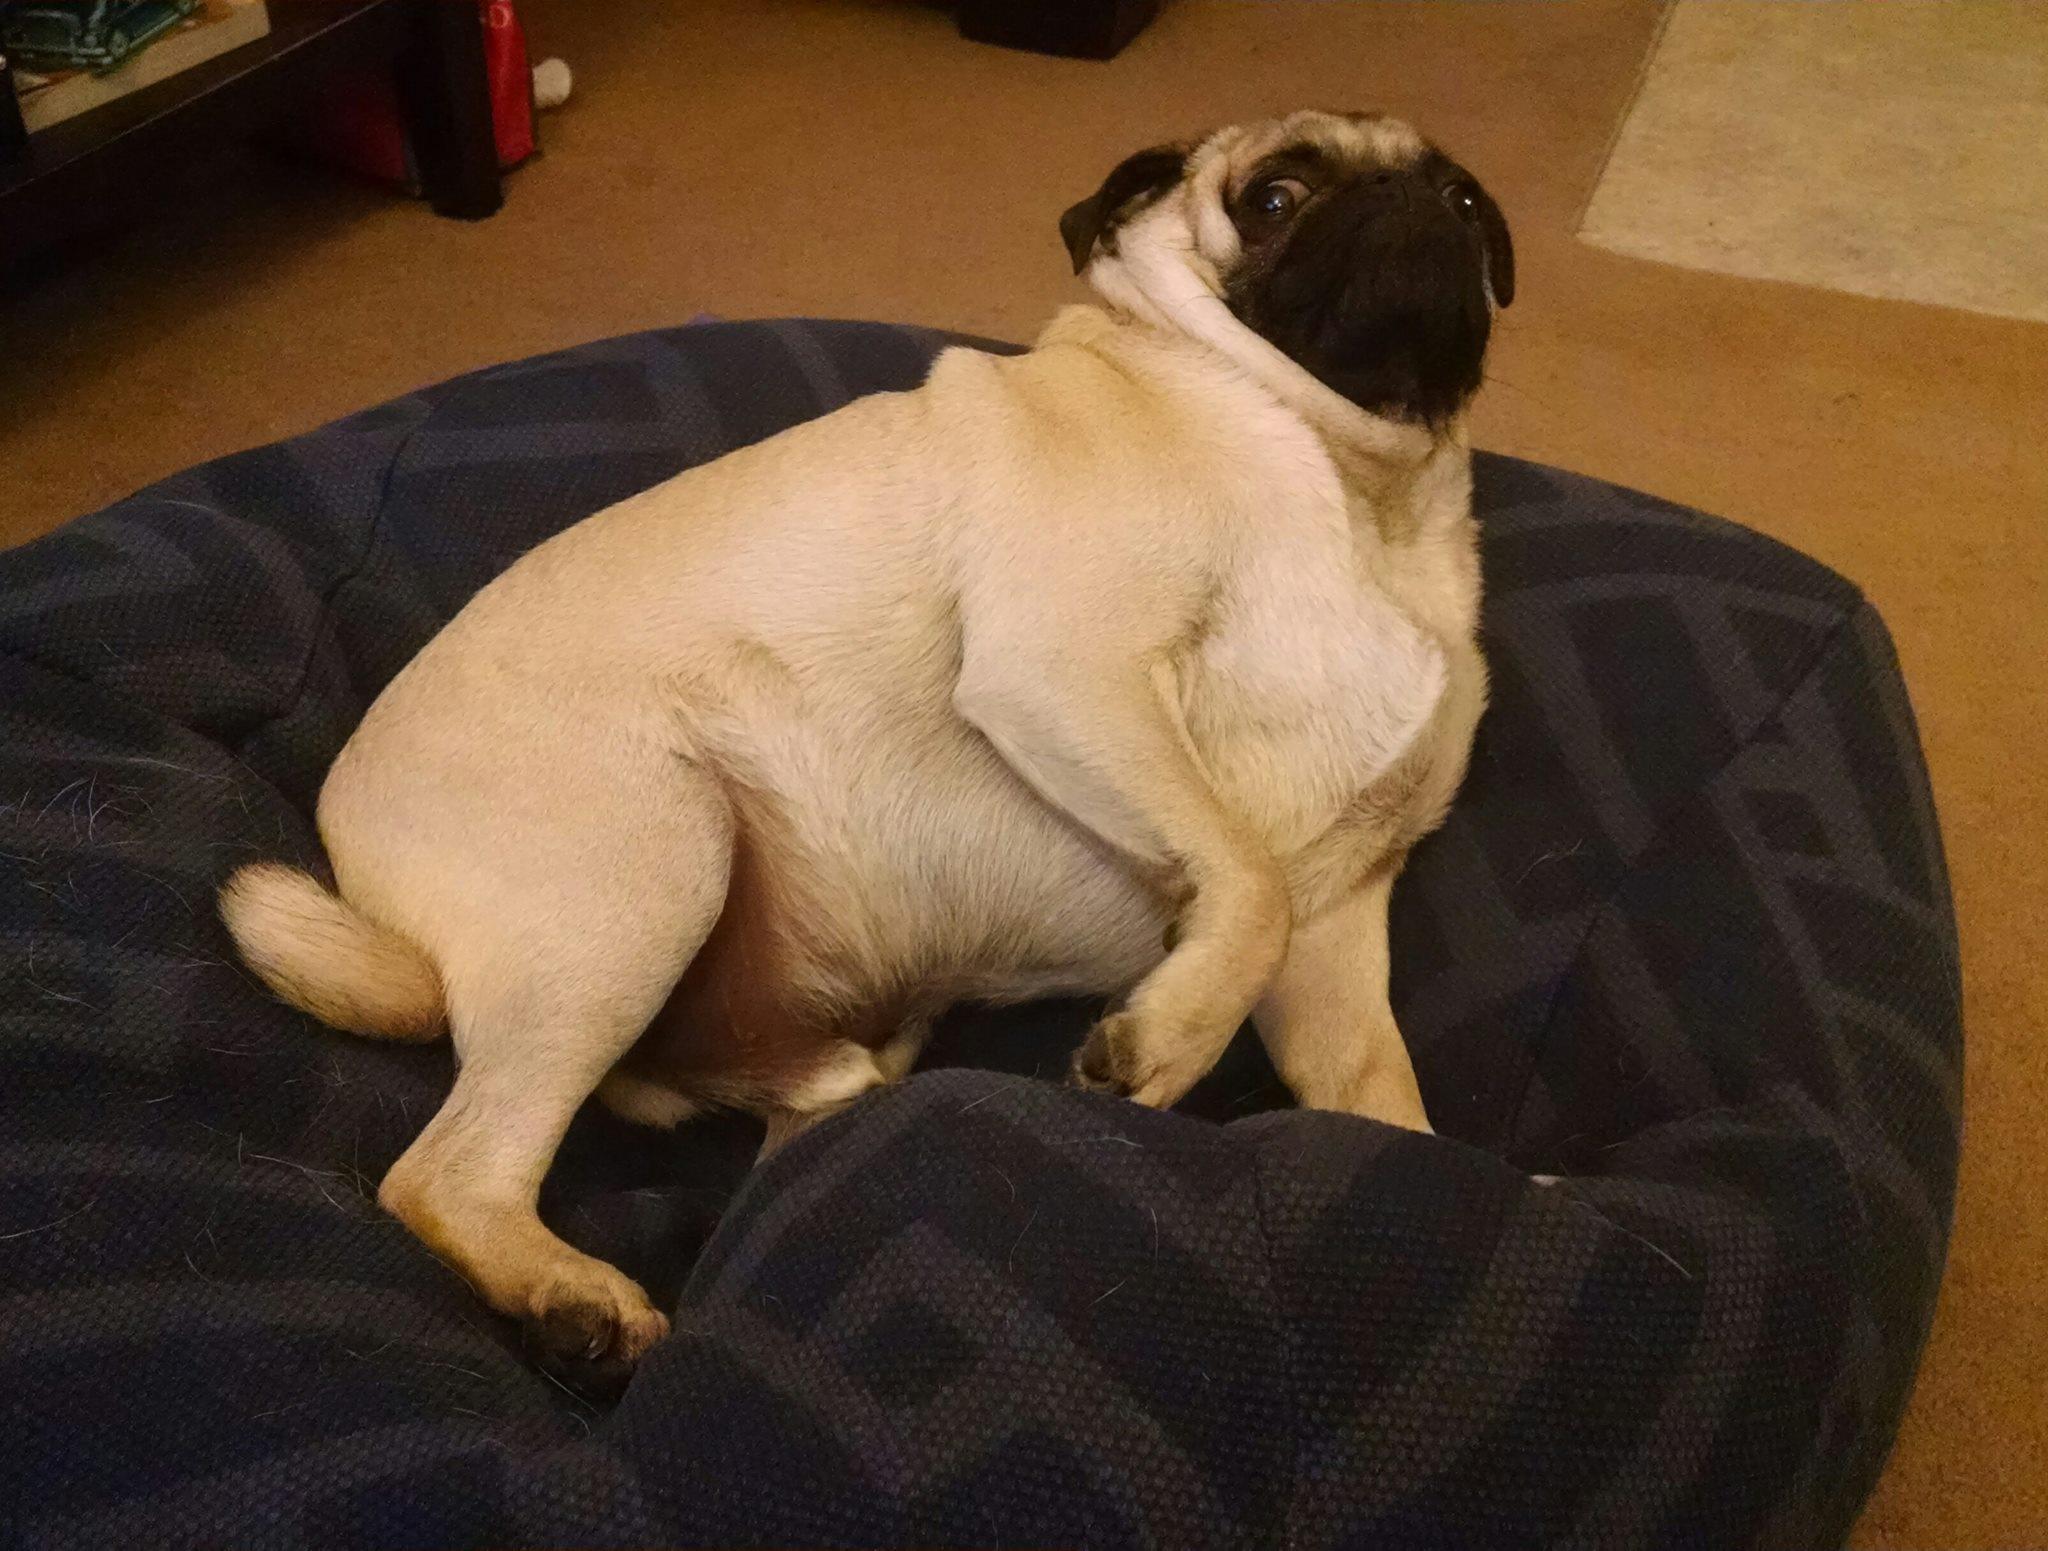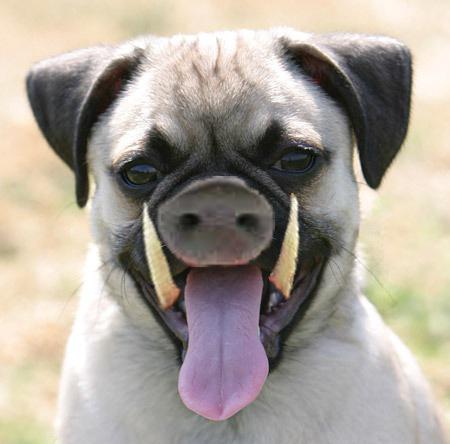The first image is the image on the left, the second image is the image on the right. For the images displayed, is the sentence "The left image shows one live pug that is not wearing a costume, and the right image includes a flat-faced dog and a pig snout" factually correct? Answer yes or no. Yes. The first image is the image on the left, the second image is the image on the right. Evaluate the accuracy of this statement regarding the images: "One of the images features a taxidermy dog.". Is it true? Answer yes or no. No. 